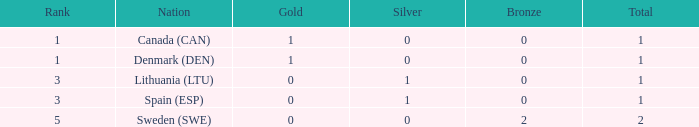How many bronze medals were won when the total is more than 1, and gold is more than 0? None. 